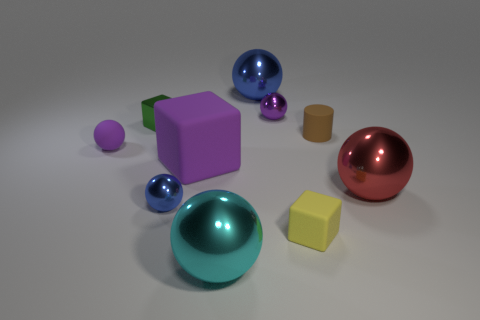Subtract all small metallic blocks. How many blocks are left? 2 Subtract all red blocks. How many blue spheres are left? 2 Subtract all purple spheres. How many spheres are left? 4 Subtract 1 blocks. How many blocks are left? 2 Subtract all spheres. How many objects are left? 4 Subtract all large blue objects. Subtract all cylinders. How many objects are left? 8 Add 1 purple matte balls. How many purple matte balls are left? 2 Add 7 red blocks. How many red blocks exist? 7 Subtract 2 purple balls. How many objects are left? 8 Subtract all brown blocks. Subtract all blue cylinders. How many blocks are left? 3 